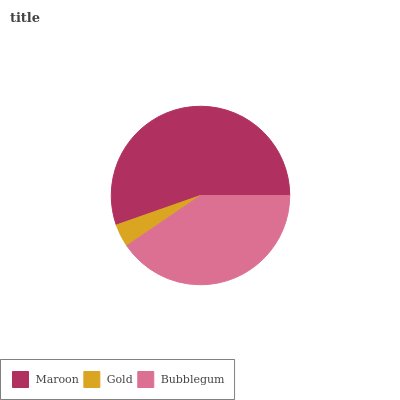Is Gold the minimum?
Answer yes or no. Yes. Is Maroon the maximum?
Answer yes or no. Yes. Is Bubblegum the minimum?
Answer yes or no. No. Is Bubblegum the maximum?
Answer yes or no. No. Is Bubblegum greater than Gold?
Answer yes or no. Yes. Is Gold less than Bubblegum?
Answer yes or no. Yes. Is Gold greater than Bubblegum?
Answer yes or no. No. Is Bubblegum less than Gold?
Answer yes or no. No. Is Bubblegum the high median?
Answer yes or no. Yes. Is Bubblegum the low median?
Answer yes or no. Yes. Is Gold the high median?
Answer yes or no. No. Is Maroon the low median?
Answer yes or no. No. 